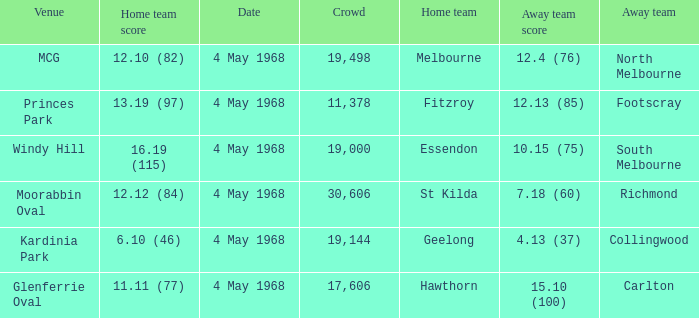What team played at Moorabbin Oval to a crowd of 19,144? St Kilda. 